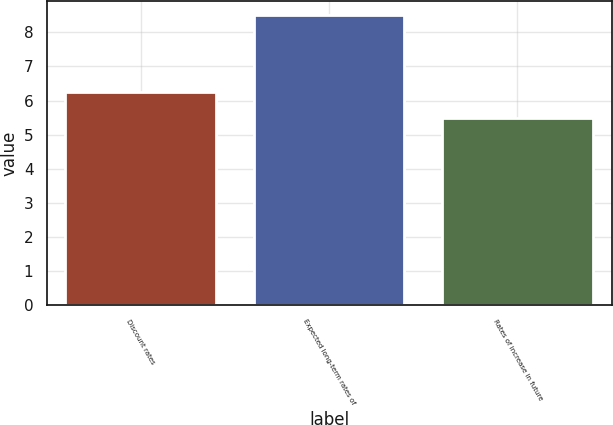<chart> <loc_0><loc_0><loc_500><loc_500><bar_chart><fcel>Discount rates<fcel>Expected long-term rates of<fcel>Rates of increase in future<nl><fcel>6.25<fcel>8.5<fcel>5.5<nl></chart> 